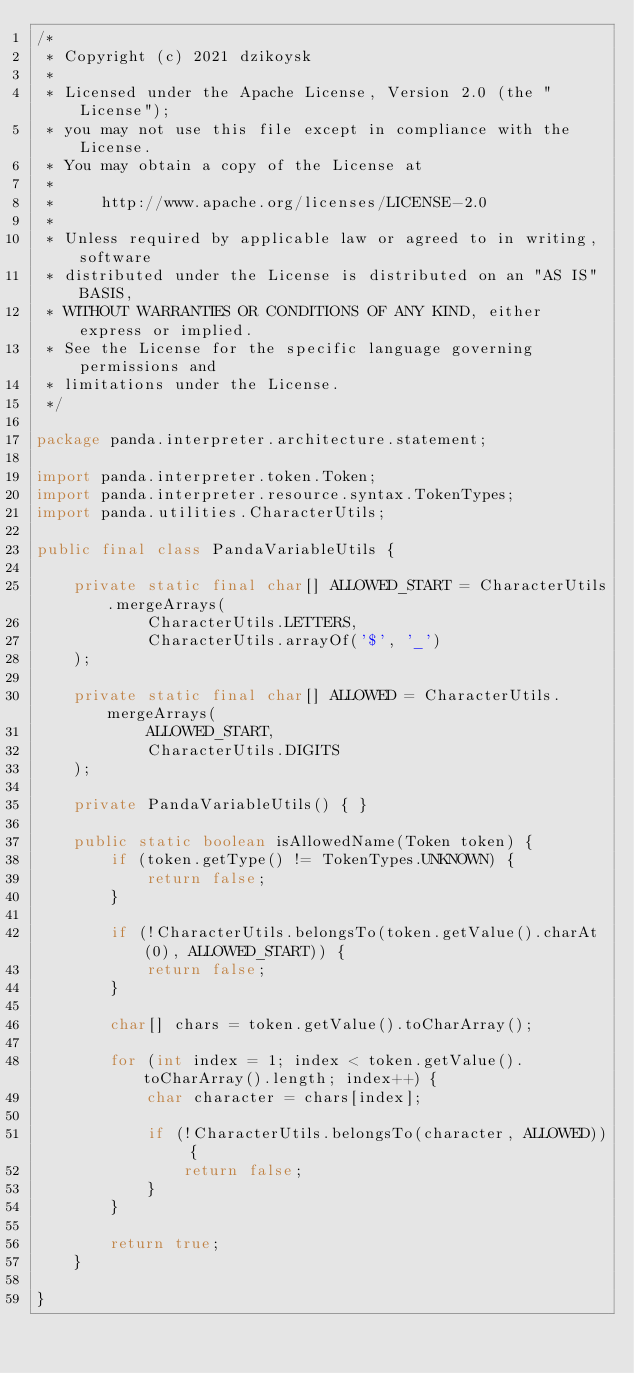<code> <loc_0><loc_0><loc_500><loc_500><_Java_>/*
 * Copyright (c) 2021 dzikoysk
 *
 * Licensed under the Apache License, Version 2.0 (the "License");
 * you may not use this file except in compliance with the License.
 * You may obtain a copy of the License at
 *
 *     http://www.apache.org/licenses/LICENSE-2.0
 *
 * Unless required by applicable law or agreed to in writing, software
 * distributed under the License is distributed on an "AS IS" BASIS,
 * WITHOUT WARRANTIES OR CONDITIONS OF ANY KIND, either express or implied.
 * See the License for the specific language governing permissions and
 * limitations under the License.
 */

package panda.interpreter.architecture.statement;

import panda.interpreter.token.Token;
import panda.interpreter.resource.syntax.TokenTypes;
import panda.utilities.CharacterUtils;

public final class PandaVariableUtils {

    private static final char[] ALLOWED_START = CharacterUtils.mergeArrays(
            CharacterUtils.LETTERS,
            CharacterUtils.arrayOf('$', '_')
    );

    private static final char[] ALLOWED = CharacterUtils.mergeArrays(
            ALLOWED_START,
            CharacterUtils.DIGITS
    );

    private PandaVariableUtils() { }

    public static boolean isAllowedName(Token token) {
        if (token.getType() != TokenTypes.UNKNOWN) {
            return false;
        }

        if (!CharacterUtils.belongsTo(token.getValue().charAt(0), ALLOWED_START)) {
            return false;
        }

        char[] chars = token.getValue().toCharArray();

        for (int index = 1; index < token.getValue().toCharArray().length; index++) {
            char character = chars[index];

            if (!CharacterUtils.belongsTo(character, ALLOWED)) {
                return false;
            }
        }

        return true;
    }

}
</code> 